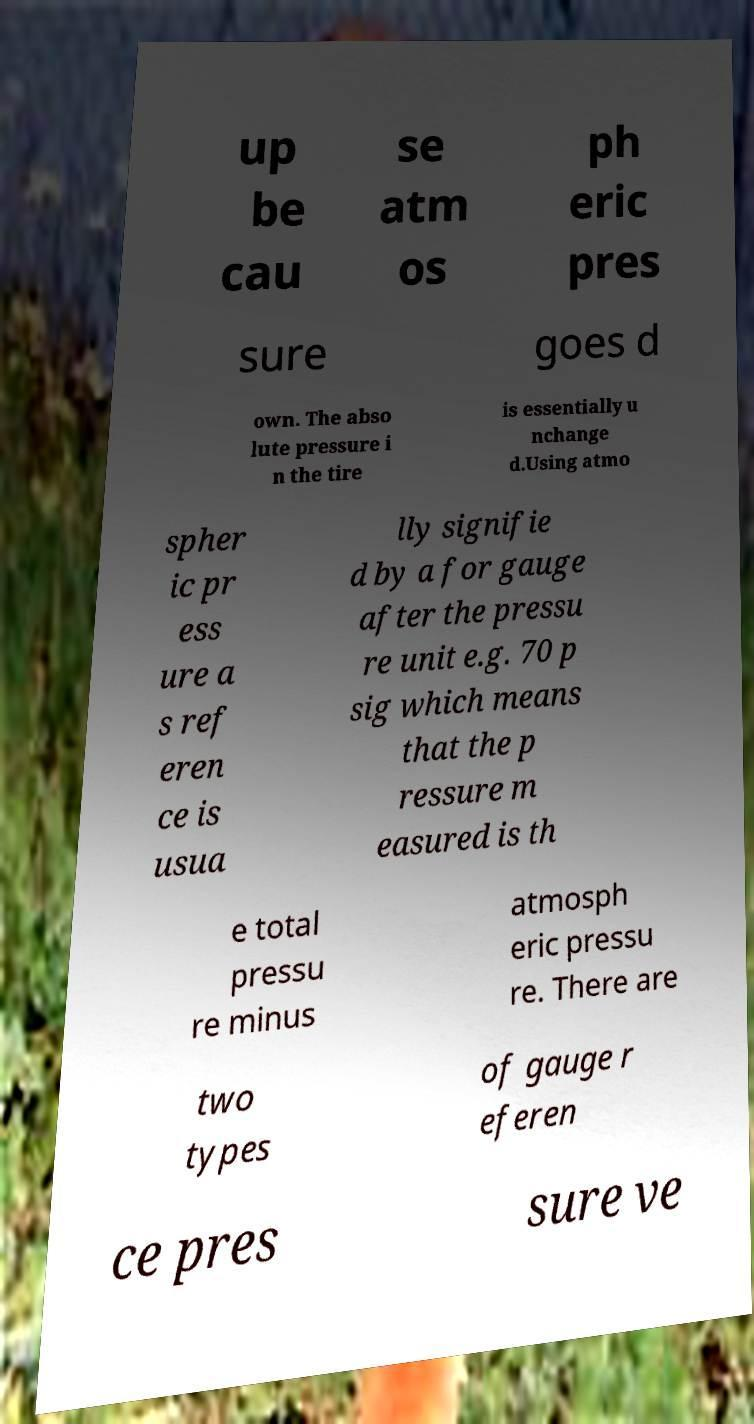There's text embedded in this image that I need extracted. Can you transcribe it verbatim? up be cau se atm os ph eric pres sure goes d own. The abso lute pressure i n the tire is essentially u nchange d.Using atmo spher ic pr ess ure a s ref eren ce is usua lly signifie d by a for gauge after the pressu re unit e.g. 70 p sig which means that the p ressure m easured is th e total pressu re minus atmosph eric pressu re. There are two types of gauge r eferen ce pres sure ve 